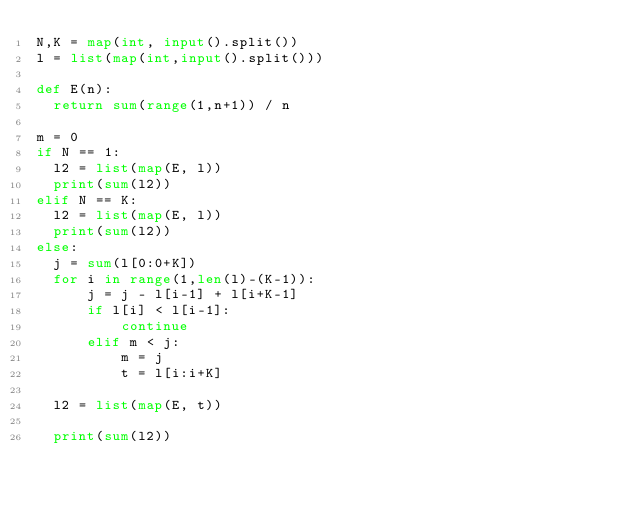Convert code to text. <code><loc_0><loc_0><loc_500><loc_500><_Python_>N,K = map(int, input().split())
l = list(map(int,input().split()))
 
def E(n):
  return sum(range(1,n+1)) / n
 
m = 0
if N == 1:
  l2 = list(map(E, l))
  print(sum(l2))
elif N == K:
  l2 = list(map(E, l))  
  print(sum(l2))
else:
  j = sum(l[0:0+K])
  for i in range(1,len(l)-(K-1)):
      j = j - l[i-1] + l[i+K-1]
      if l[i] < l[i-1]:
          continue
      elif m < j:
          m = j
          t = l[i:i+K]

  l2 = list(map(E, t))
 
  print(sum(l2))</code> 